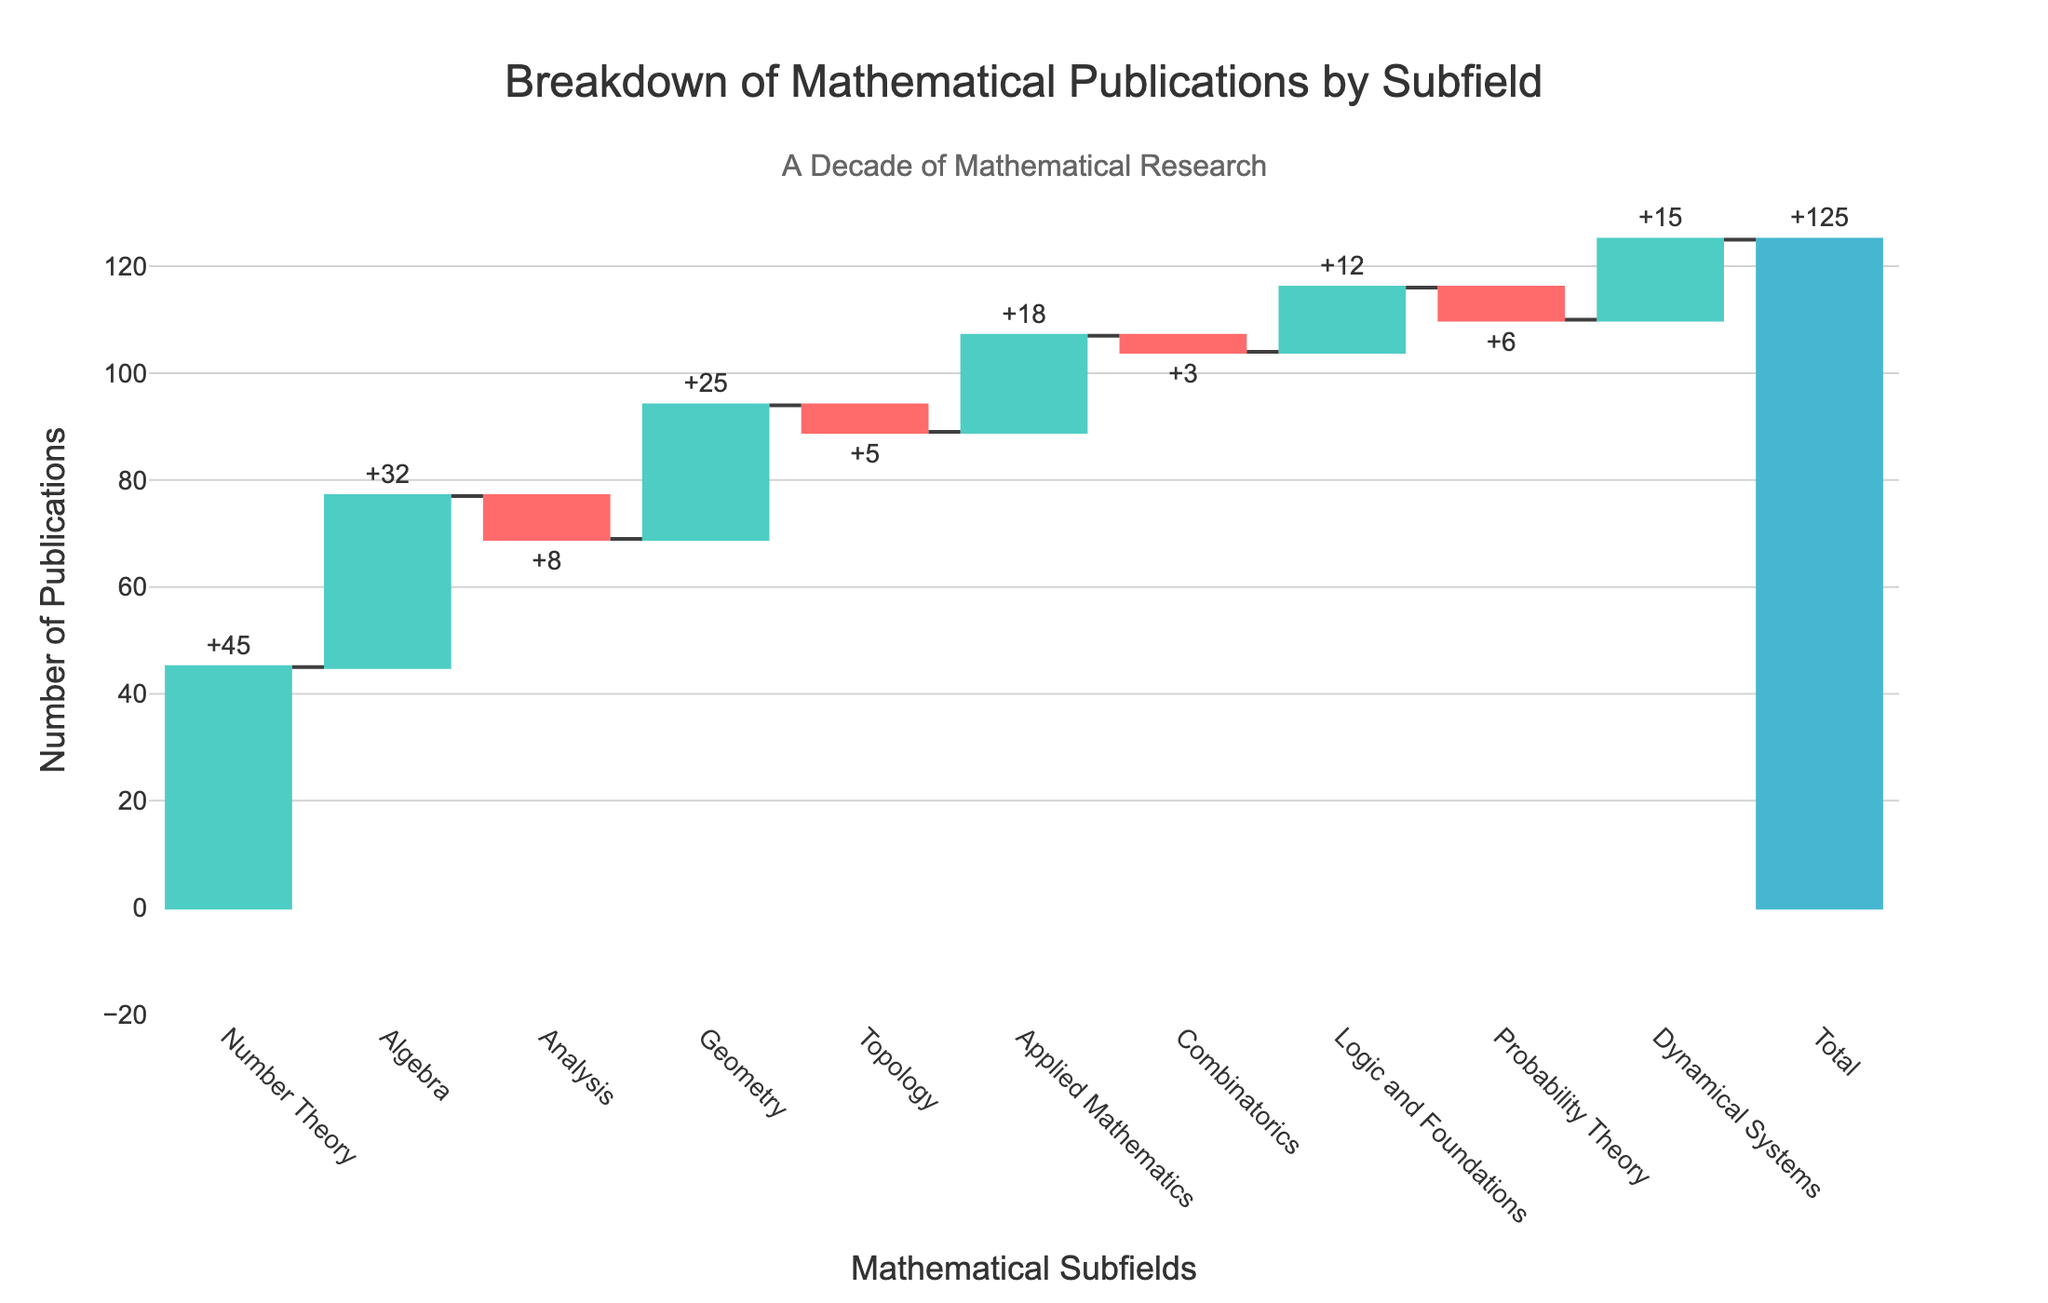What is the title of the figure? The title is prominently displayed at the top of the chart. It reads "Breakdown of Mathematical Publications by Subfield."
Answer: Breakdown of Mathematical Publications by Subfield Which subfield has the highest number of publications? The highest bar in the chart corresponds to "Number Theory" with a value of 45 publications.
Answer: Number Theory How many subfields have a negative number of publications? The chart shows Analysis (-8), Topology (-5), Combinatorics (-3), and Probability Theory (-6) with negative values. There are 4 such subfields.
Answer: 4 What is the total number of publications across all subfields? The bar labeled 'Total' at the end sums up all categories, showing a value of 125.
Answer: 125 Which subfield has the fewest publications in positive numbers, and how many are there? Among the positive values, "Logic and Foundations" has the fewest publications with a value of 12.
Answer: Logic and Foundations, 12 How much more popular is Number Theory compared to Geometry in terms of publication numbers? Number Theory has 45 publications while Geometry has 25 publications. The difference is 45 - 25 = 20.
Answer: 20 Calculate the net contribution of negative subfields to the total. The sum of negative values is -8 (Analysis) + (-5) (Topology) + (-3) (Combinatorics) + (-6) (Probability Theory) = -22.
Answer: -22 Which two subfields together contribute a total of 57 publications? Number Theory (45) and Analysis (-8) contribute 45 + -8 = 37, Number Theory and Geometry (25) contribute 45 + 25 = 70, and so on. The correct pair is Number Theory (45) and Algebra (32), giving 45 + 32 = 77, but this exceeds 57. After checking all combinations: Algebra (32) and Dynamical Systems (15) together make 32 + 15 = 47, which is closer but not 57. The right pair is Number Theory (45) and Logic and Foundations (12), giving 45 + 12 = 57.
Answer: Number Theory and Logic and Foundations What is the combined total of publications in Algebra, Geometry, and Applied Mathematics? Sum the values of Algebra (32), Geometry (25), and Applied Mathematics (18). The total is 32 + 25 + 18 = 75.
Answer: 75 Identify the subfield with the smallest absolute value change and state the value. The smallest absolute values are -3 (Combinatorics) and 12 (Logic and Foundations). The smallest is Combinatorics with an absolute value of 3.
Answer: Combinatorics, 3 